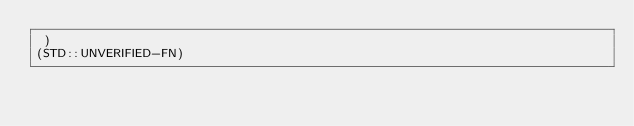Convert code to text. <code><loc_0><loc_0><loc_500><loc_500><_Lisp_> )
(STD::UNVERIFIED-FN)
</code> 